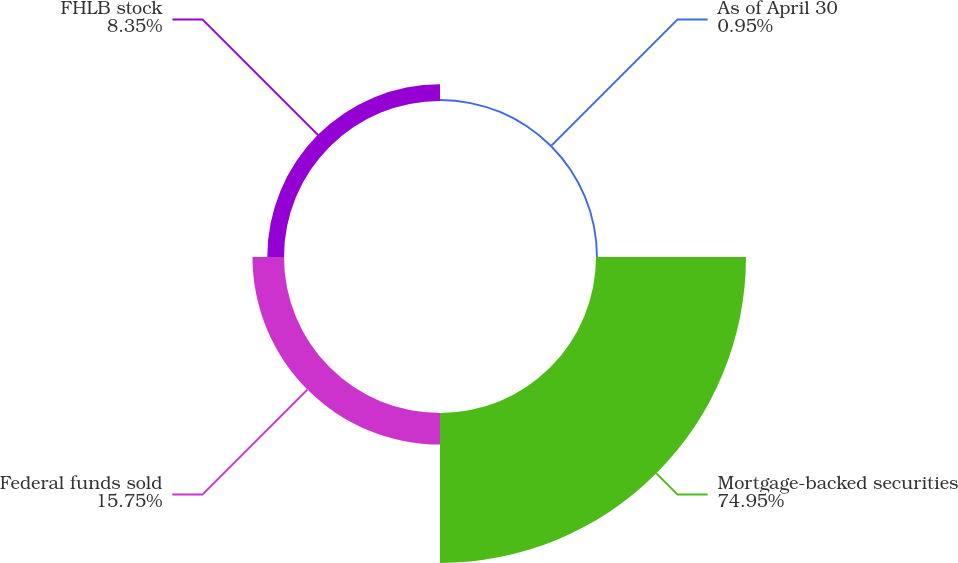<chart> <loc_0><loc_0><loc_500><loc_500><pie_chart><fcel>As of April 30<fcel>Mortgage-backed securities<fcel>Federal funds sold<fcel>FHLB stock<nl><fcel>0.95%<fcel>74.94%<fcel>15.75%<fcel>8.35%<nl></chart> 